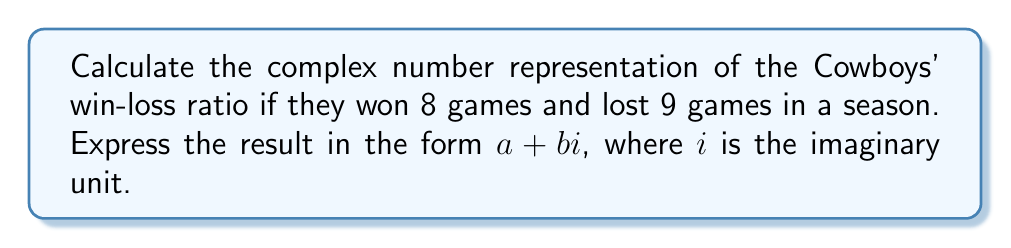Teach me how to tackle this problem. Let's approach this step-by-step:

1) The win-loss ratio can be expressed as a fraction: $\frac{\text{wins}}{\text{losses}} = \frac{8}{9}$

2) To represent this as a complex number, we need to convert it to the form $a + bi$. In this case, the real part $a$ will be the result of the division, and the imaginary part $b$ will be 0.

3) Performing the division:

   $$\frac{8}{9} = 0.\overline{8}$$

4) This repeating decimal can be expressed as:

   $$0.\overline{8} = 0.888888...$$

5) In complex number form, this becomes:

   $$0.\overline{8} + 0i$$

6) We can approximate this to a reasonable number of decimal places, say 4:

   $$0.8889 + 0i$$

Thus, the complex number representation of the Cowboys' win-loss ratio is approximately $0.8889 + 0i$.
Answer: $0.8889 + 0i$ 